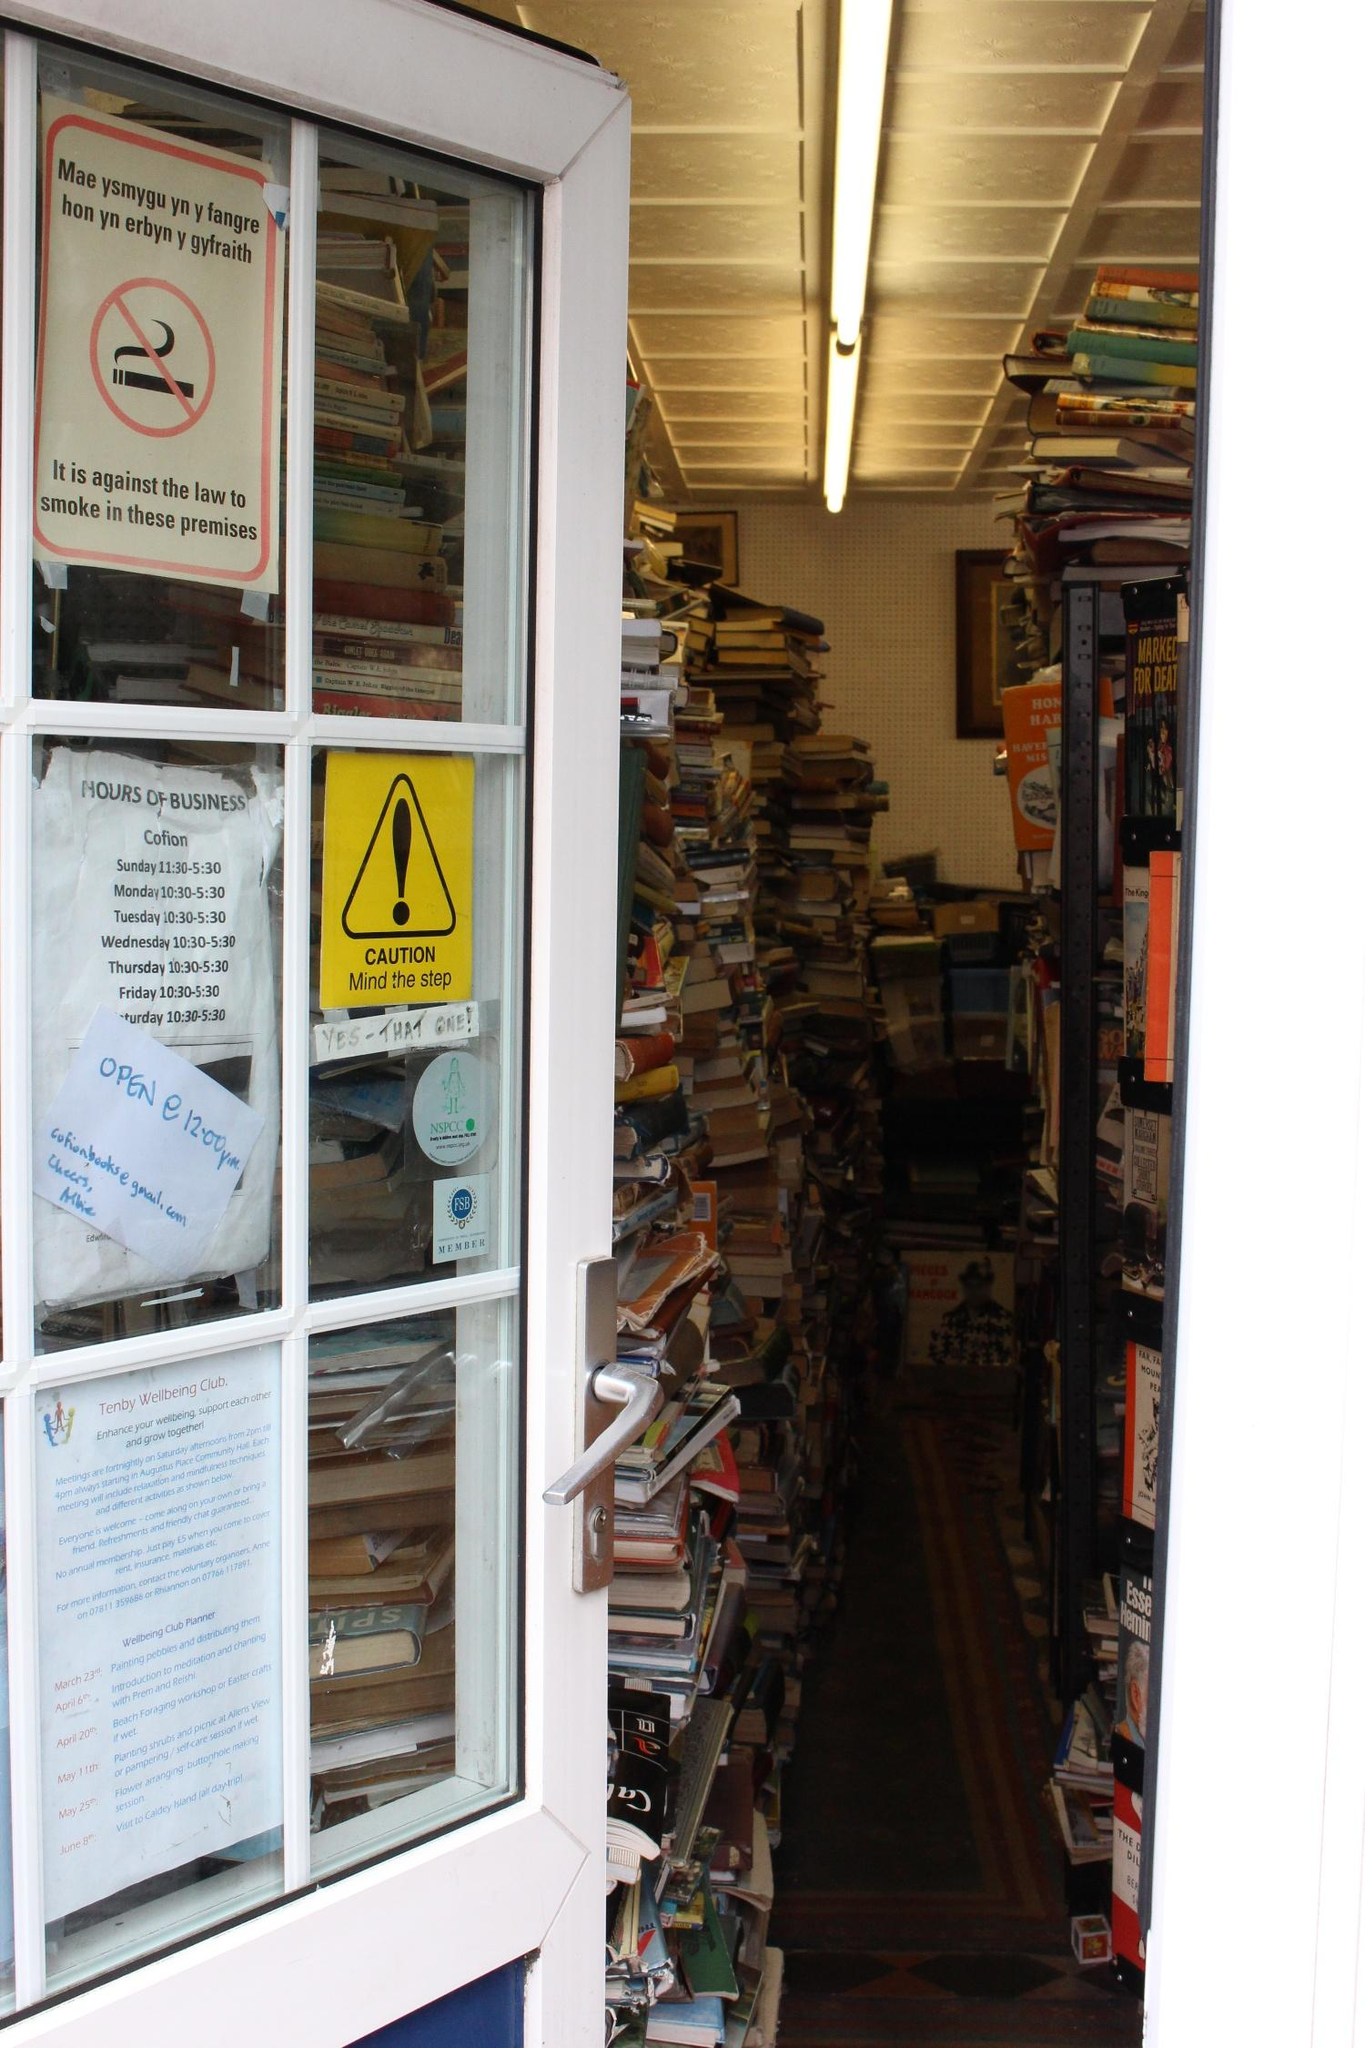Analyze the image in a comprehensive and detailed manner. The image captures an intriguing view of a quaint and densely stocked bookstore through a window framed in white. There are numerous signs adhered to the window, including a bilingual no-smoking sign, indicating the location might cater to a diverse community or be situated in a bilingual region. Another sign warns visitors to 'Mind the step,' signifying there may be uneven flooring inside. The reflection on the window suggests an urban street setting outside. Inside, an array of books is haphazardly arranged on shelves and piles that reach the ceiling, suggesting a treasure trove of literary findings. The lighting casts a warm glow over the scene, enhancing the inviting feel of this trove. Overall, the image conveys a snug, almost timeless atmosphere, beckoning readers to explore the depths of stories contained within. 